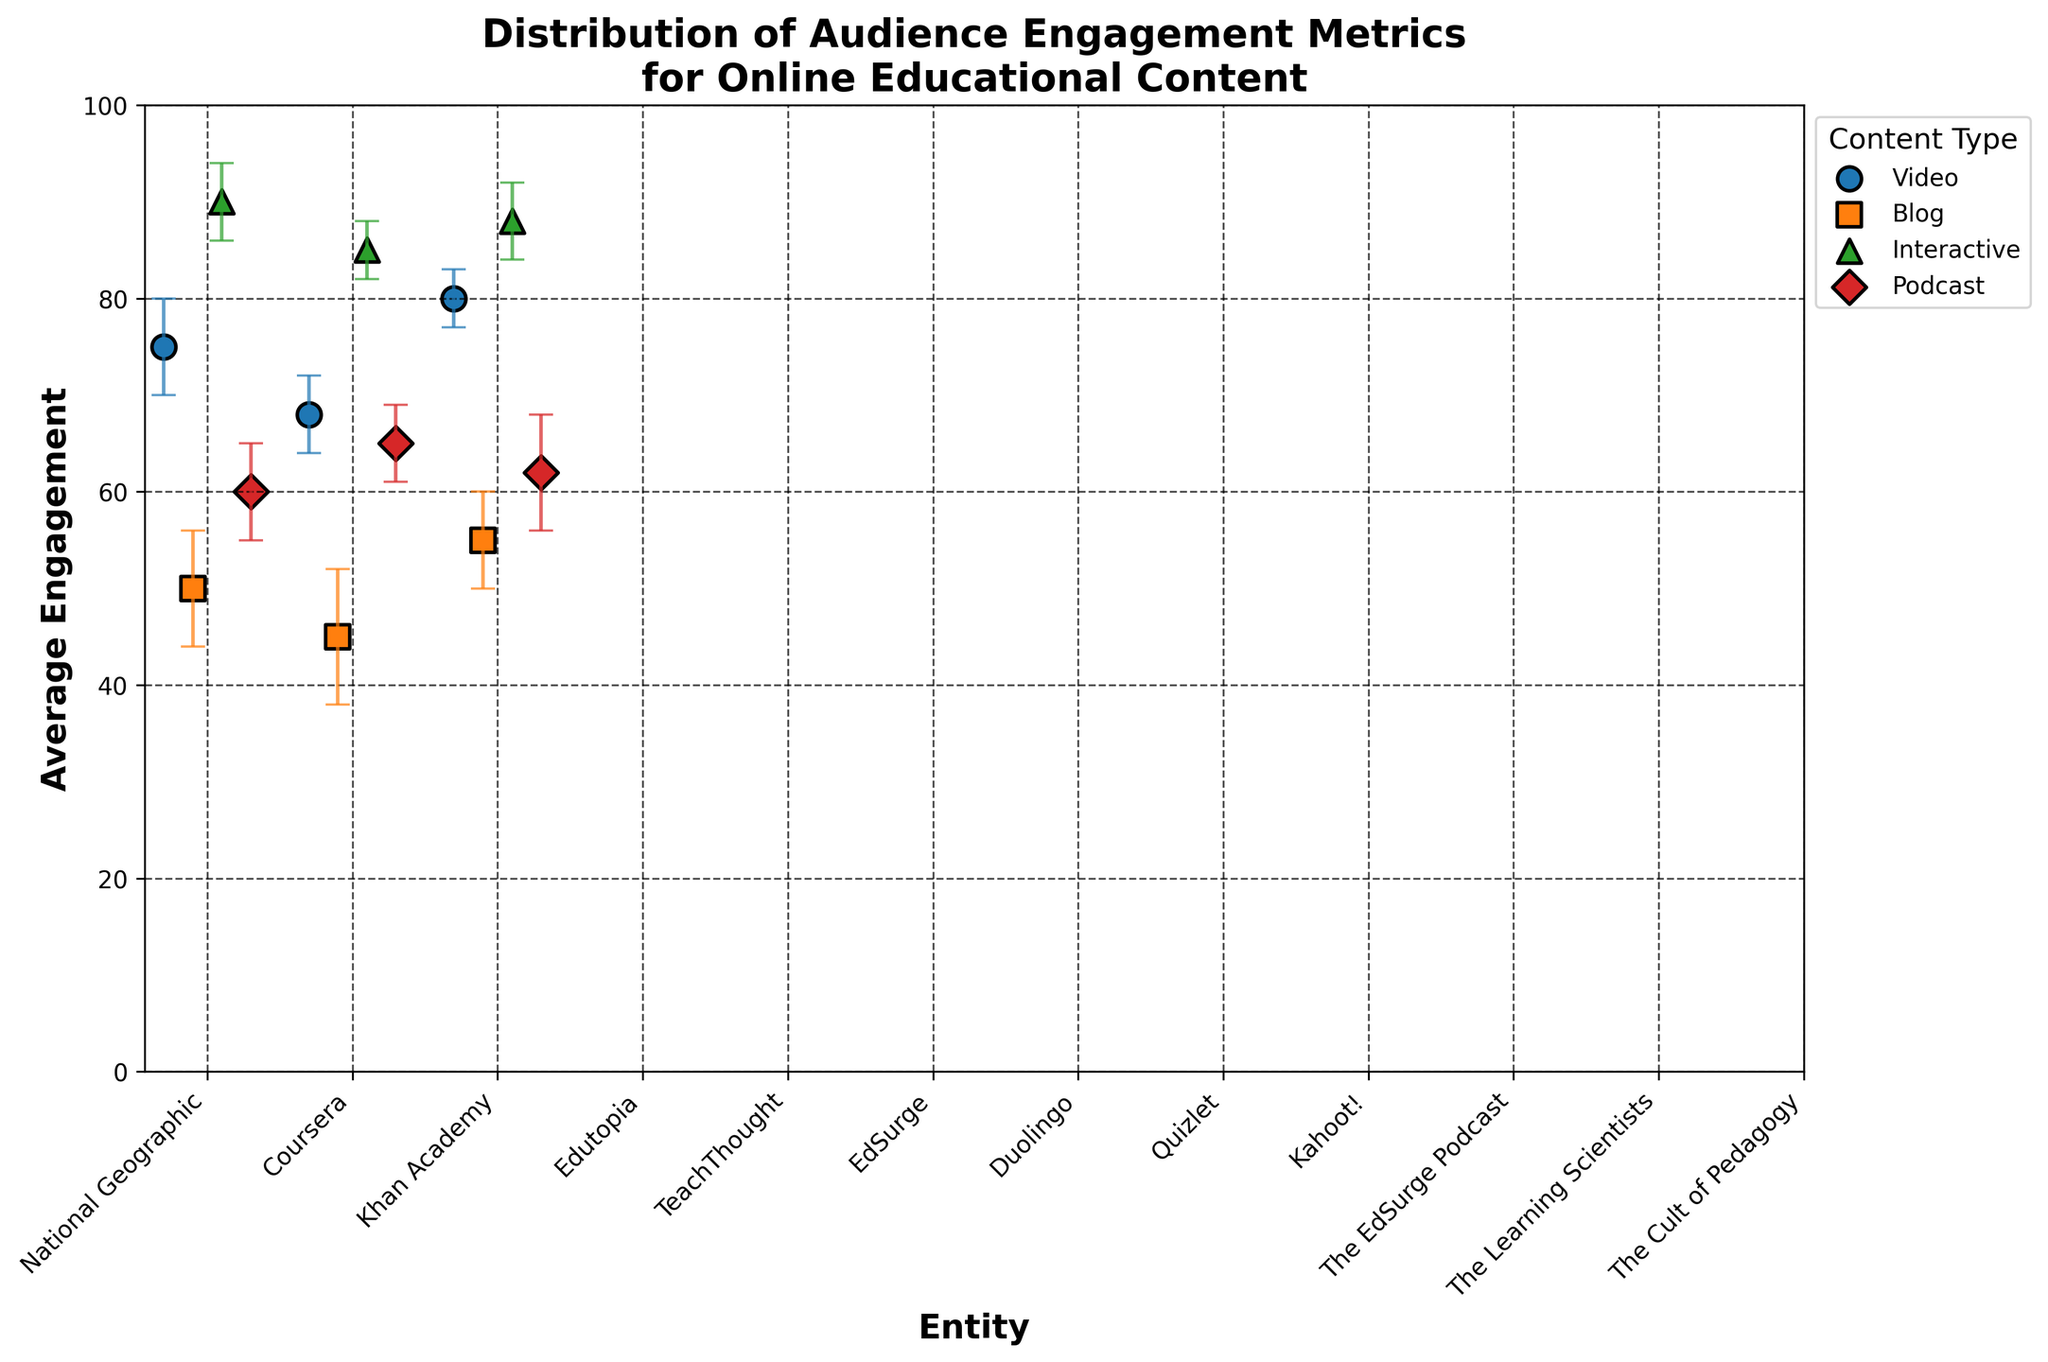What is the title of the figure? The title of the figure is clearly stated at the top. It is 'Distribution of Audience Engagement Metrics for Online Educational Content'.
Answer: Distribution of Audience Engagement Metrics for Online Educational Content How many types of educational content are represented in the figure? By observing the legend on the right side of the figure, we can see that there are four different types of educational content: Video, Blog, Interactive, and Podcast.
Answer: 4 Which entity has the highest average engagement? To determine the highest average engagement, we scan the y-axis values for each data point. Duolingo under the Interactive content type has the highest value at 90.
Answer: Duolingo How does the average engagement of Khan Academy compare to Coursera for Video content? We locate both Khan Academy and Coursera under the Video content type and compare their y-axis values. Khan Academy has an average engagement of 80, while Coursera has 68. Therefore, Khan Academy has a higher engagement than Coursera.
Answer: Khan Academy is higher What is the range of average engagement for Blog content? The range is found by subtracting the lowest engagement value from the highest within the Blog content markers. The lowest is TeachThought with 45 and the highest is EdSurge with 55. So, 55 - 45 = 10.
Answer: 10 Which type of content has the most consistent engagement values? To find the most consistent values, we look for the content type with the smallest error bars overall. The Interactive content type has smaller error bars compared to other content types, showing more consistency.
Answer: Interactive What is the average engagement for Podcast content, and what is the maximum error margin within this type? For Podcast, we average the Engagement values (60 + 65 + 62) which gives (187 / 3) = 62.33. The error margins are 5, 4, and 6, so the maximum is 6.
Answer: Average: 62.33, Maximum Error Margin: 6 Which Video content provider has the smallest error margin? We look at the error bars for the three entities under Video content. Khan Academy has the smallest error margin with 3.
Answer: Khan Academy By how much does the engagement of the highest Podcast content (The Learning Scientists) exceed the lowest Blog content (TeachThought)? The Learning Scientists have an engagement of 65 (highest Podcast) and TeachThought has 45 (lowest Blog). 65 - 45 = 20.
Answer: 20 